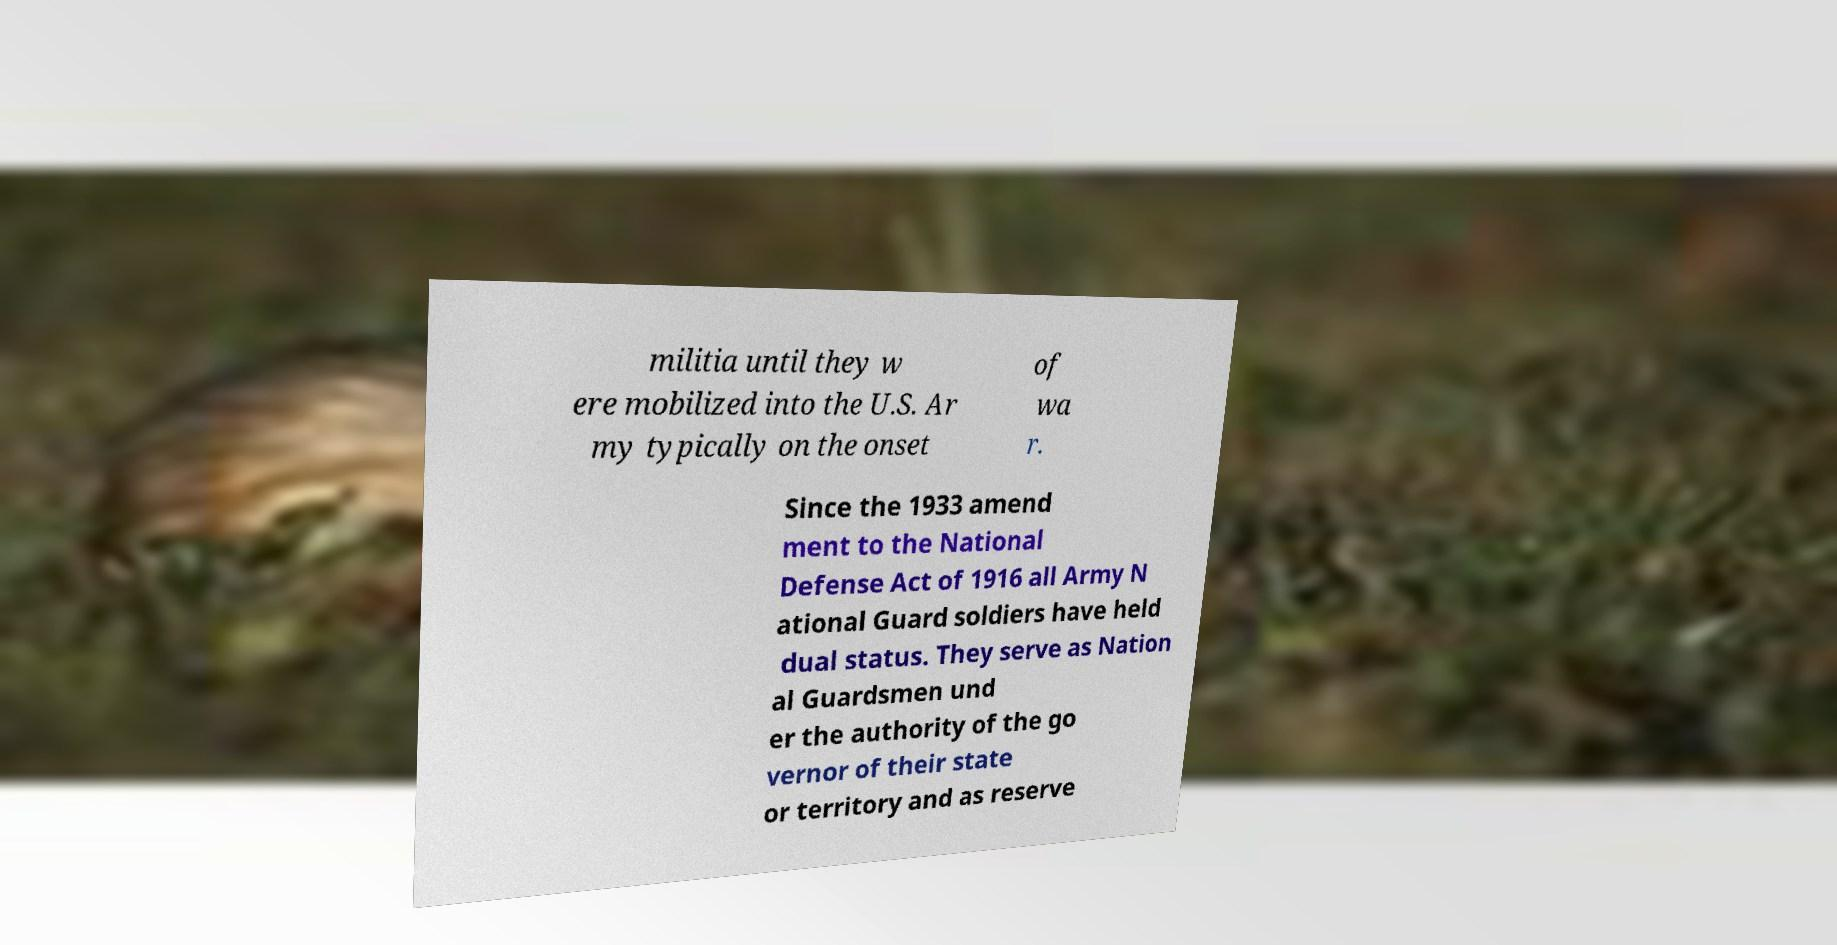For documentation purposes, I need the text within this image transcribed. Could you provide that? militia until they w ere mobilized into the U.S. Ar my typically on the onset of wa r. Since the 1933 amend ment to the National Defense Act of 1916 all Army N ational Guard soldiers have held dual status. They serve as Nation al Guardsmen und er the authority of the go vernor of their state or territory and as reserve 